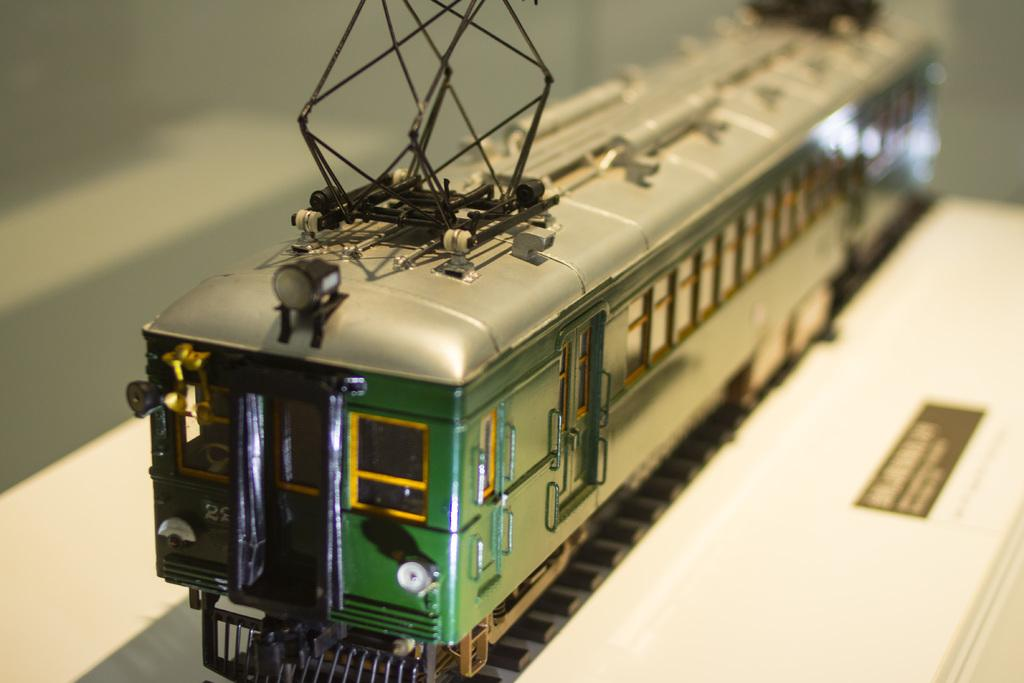What is the main subject of the image? The main subject of the image is a toy train. Can you describe the setting of the toy train in the image? The toy train is on a track. How does the toy train turn around on the track in the image? A: The image does not show the toy train turning around on the track, so we cannot determine how it would turn. 